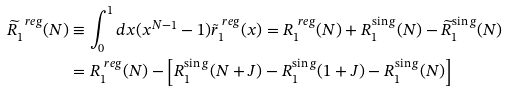Convert formula to latex. <formula><loc_0><loc_0><loc_500><loc_500>\widetilde { R } _ { 1 } ^ { \ r e g } ( N ) & \equiv \int _ { 0 } ^ { 1 } d x ( x ^ { N - 1 } - 1 ) \tilde { r } _ { 1 } ^ { \ r e g } ( x ) = R _ { 1 } ^ { \ r e g } ( N ) + R _ { 1 } ^ { \sin g } ( N ) - \widetilde { R } _ { 1 } ^ { \sin g } ( N ) \\ & = R _ { 1 } ^ { \ r e g } ( N ) - \left [ R _ { 1 } ^ { \sin g } ( N + J ) - R _ { 1 } ^ { \sin g } ( 1 + J ) - R _ { 1 } ^ { \sin g } ( N ) \right ]</formula> 